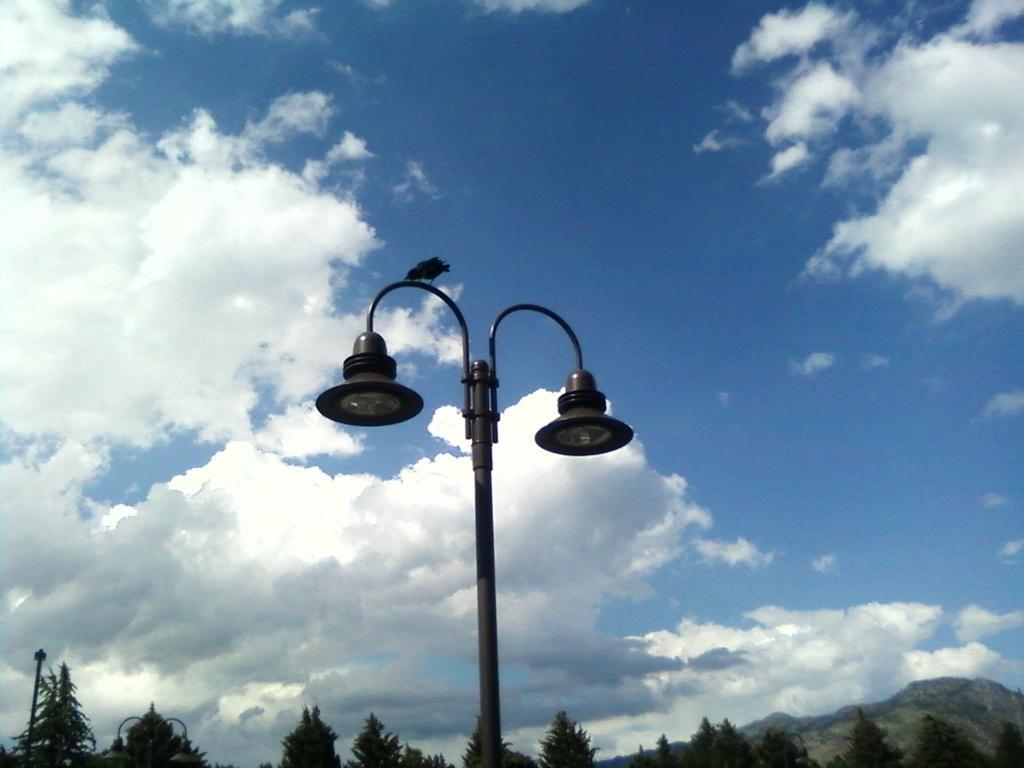In one or two sentences, can you explain what this image depicts? At the bottom of the picture there are trees, hill and a street light. In the center of the picture there are street light and a bird. Sky is bit cloudy. 